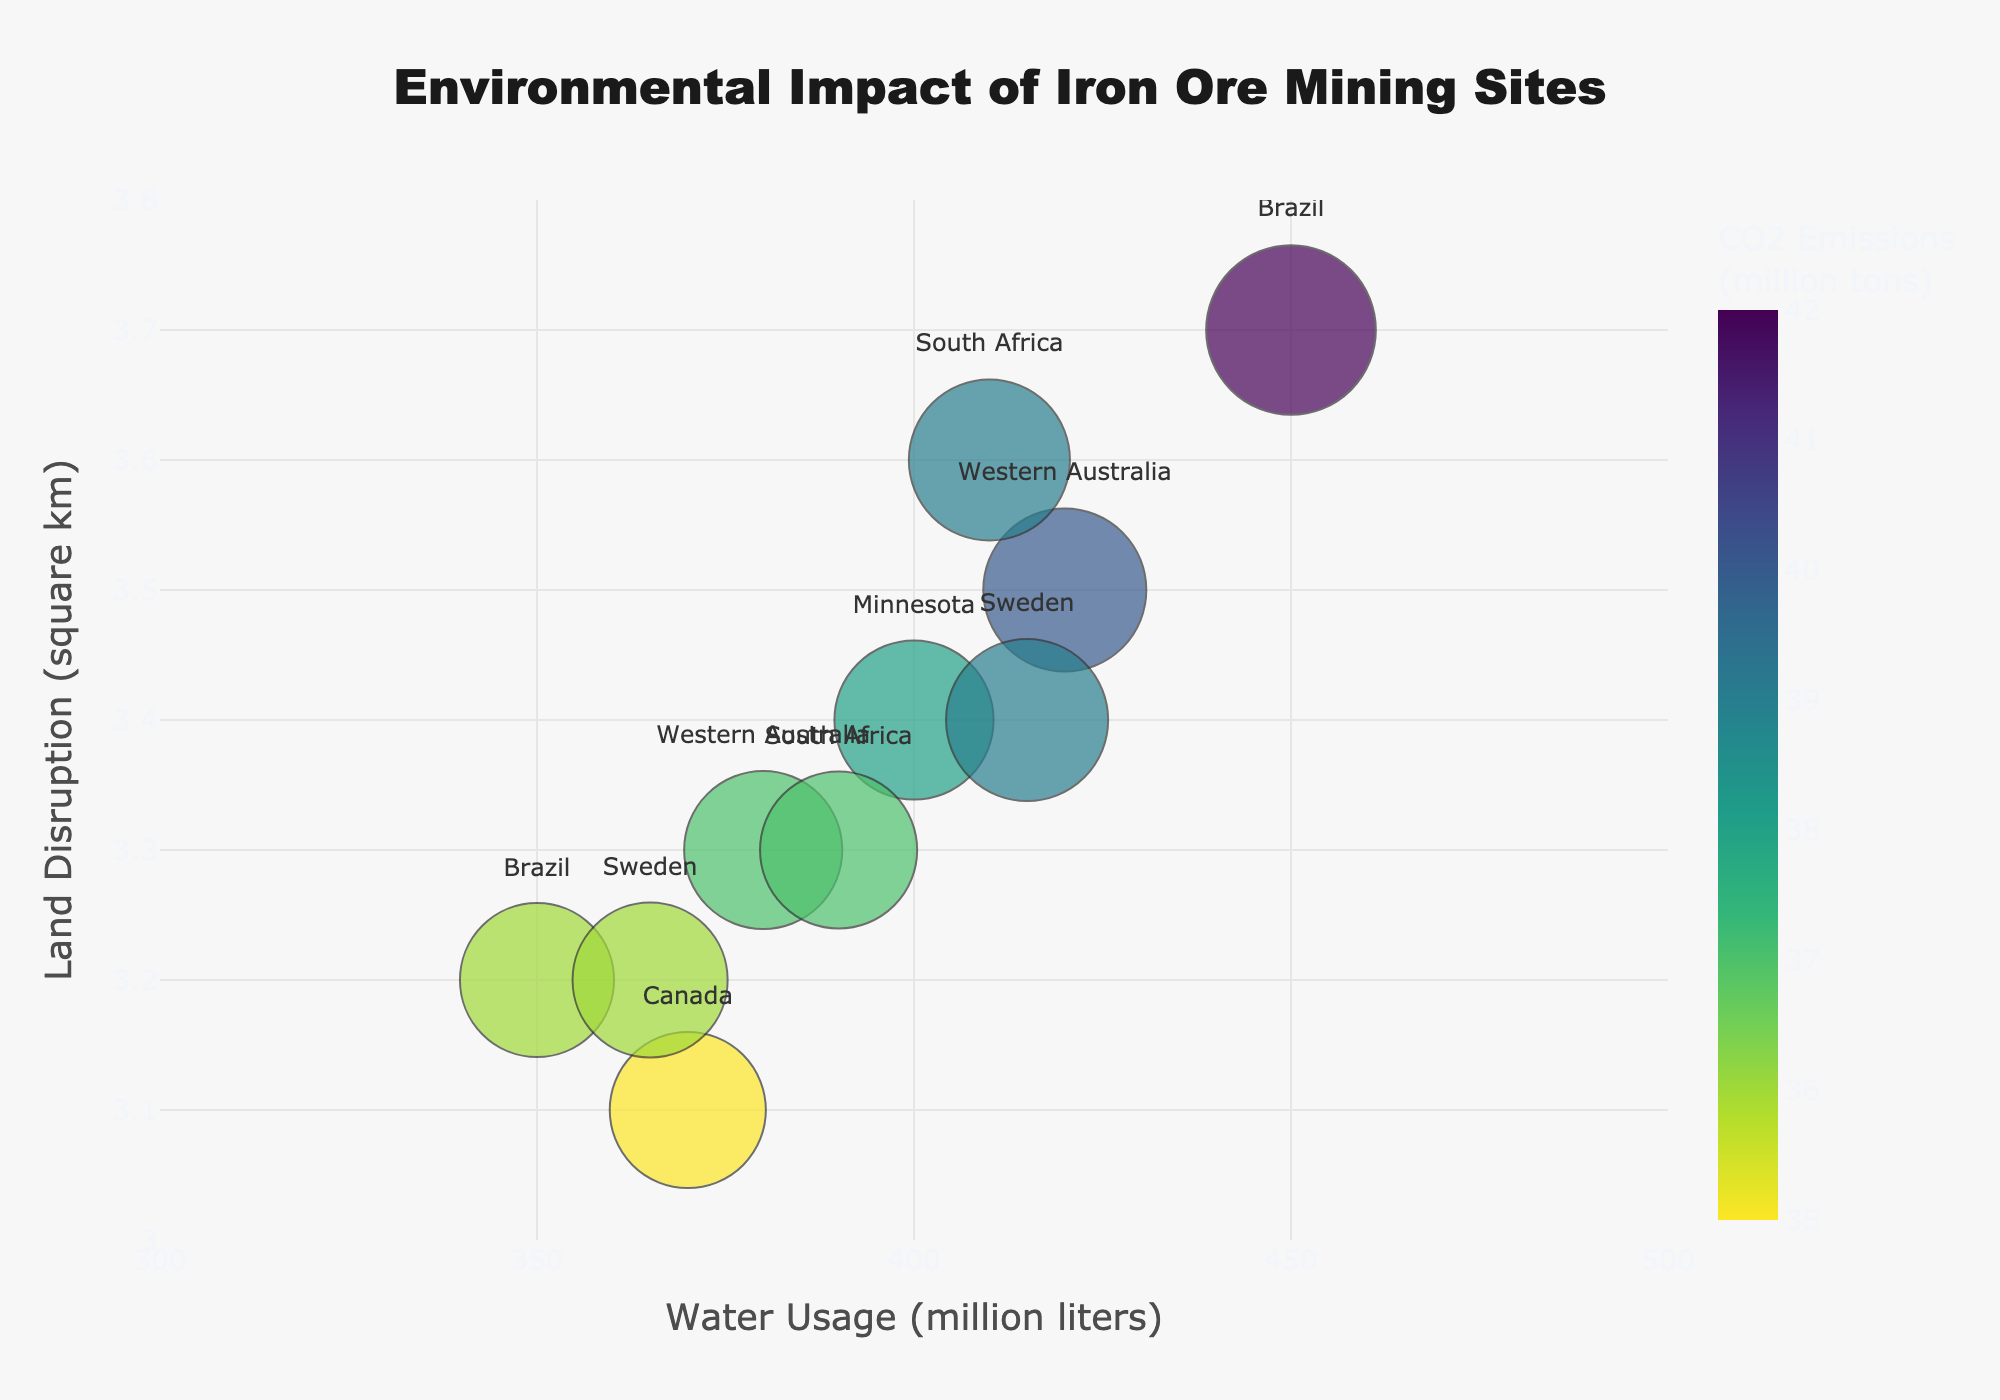How many mining sites are displayed in the figure? Count the number of data points (bubbles) in the plot.
Answer: 10 Which region has the highest water usage? Since "Water Usage" is on the x-axis, look for the point farthest to the right, then check its text label, which indicates the region.
Answer: Brazil Which mining site has the lowest CO2 emissions? Look at the color scale, where the lighter color represents lower CO2 emissions, and hover over the data points to find the mining site with the lightest color.
Answer: Labrador Trough Which mining site in Sweden has a higher land disruption, Kiruna or Malmberget? Locate the two mining sites labeled "Sweden" on the plot and compare their y-axis positions, which represent land disruption.
Answer: Kiruna What is the total environmental impact score for mining sites in Western Australia? Identify the bubbles associated with "Western Australia", then sum up their environmental impact values: Mount Whaleback (8.4) + Roy Hill (7.9).
Answer: 16.3 Which has higher water usage, Carajás or Roy Hill? Locate these two mining sites on the x-axis, and compare their positions.
Answer: Carajás What is the average land disruption for mining sites in South Africa? Identify the two South African mining sites, Sishen (3.6) and Kumba (3.3), and calculate the average: (3.6 + 3.3) / 2.
Answer: 3.45 Compare the environmental impact of Mount Whaleback and Mesabi Range, which is higher? Check the sizes of the bubbles for each mining site, which represent their environmental impact scores.
Answer: Mount Whaleback What is the range of CO2 emissions for mining sites in Canada? Find the CO2 emissions values for the Canadian mining site (Labrador Trough: 35) and determine the range. Since there's only one site, the range is 0.
Answer: 0 Which region has the lowest environmental impact score, and what is the score? Compare the sizes of all bubbles and find the smallest one, then check the corresponding region and its environmental impact score.
Answer: Brazil, Brucutu, 7.5 